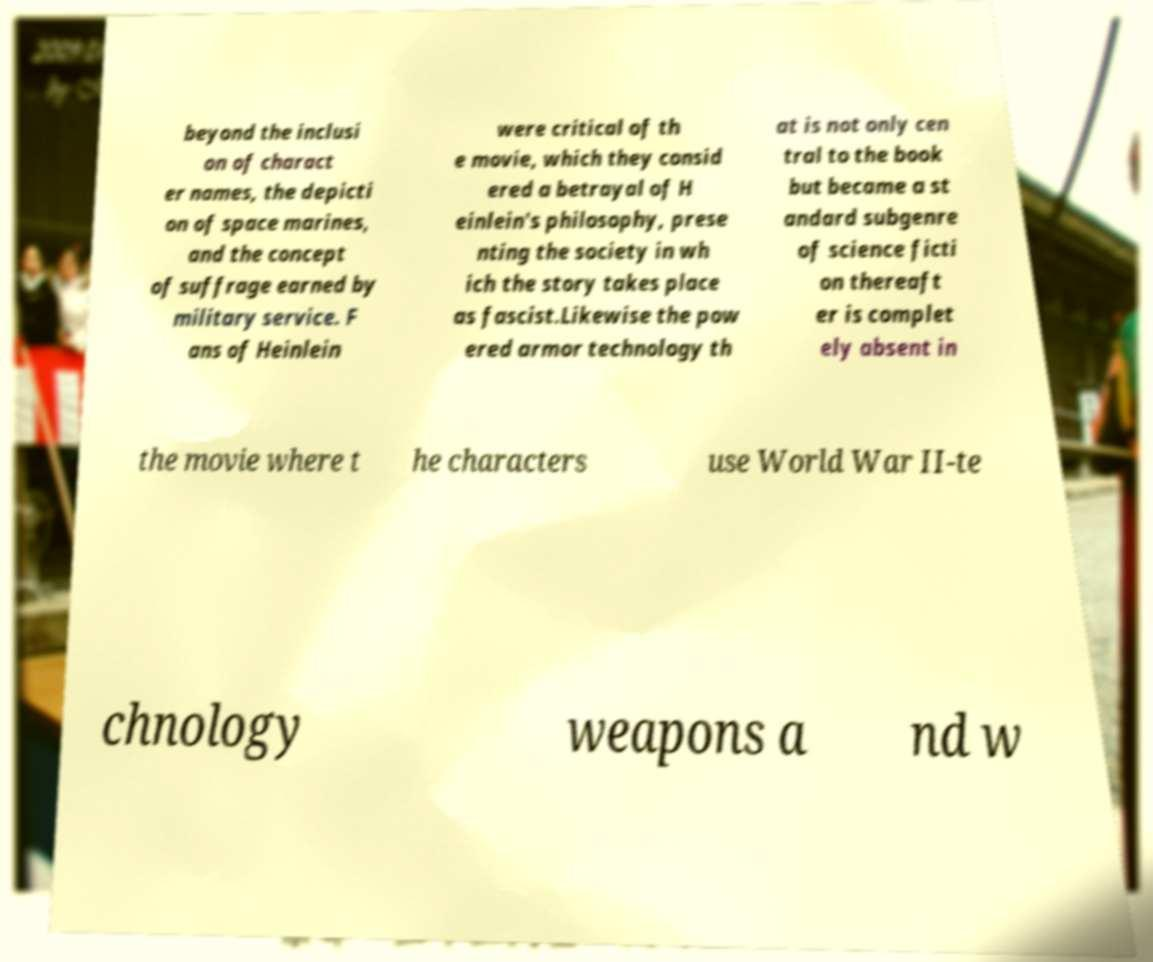What messages or text are displayed in this image? I need them in a readable, typed format. beyond the inclusi on of charact er names, the depicti on of space marines, and the concept of suffrage earned by military service. F ans of Heinlein were critical of th e movie, which they consid ered a betrayal of H einlein's philosophy, prese nting the society in wh ich the story takes place as fascist.Likewise the pow ered armor technology th at is not only cen tral to the book but became a st andard subgenre of science ficti on thereaft er is complet ely absent in the movie where t he characters use World War II-te chnology weapons a nd w 